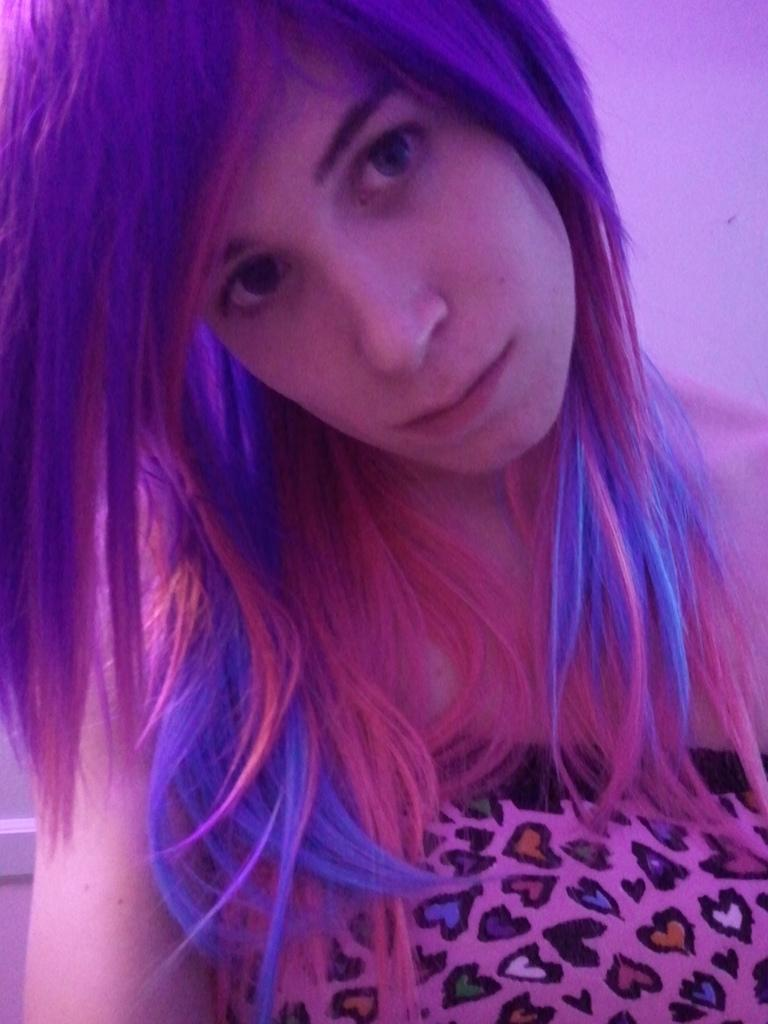Who is present in the image? There is a woman in the image. What can be seen in the background of the image? There is a wall in the background of the image. What type of cakes were served at the hot aftermath event in the image? There is no event, cakes, or mention of heat in the image; it simply features a woman and a wall in the background. 